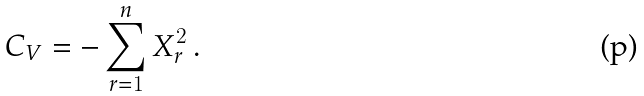Convert formula to latex. <formula><loc_0><loc_0><loc_500><loc_500>C _ { V } = - \sum _ { r = 1 } ^ { n } X _ { r } ^ { 2 } \, .</formula> 